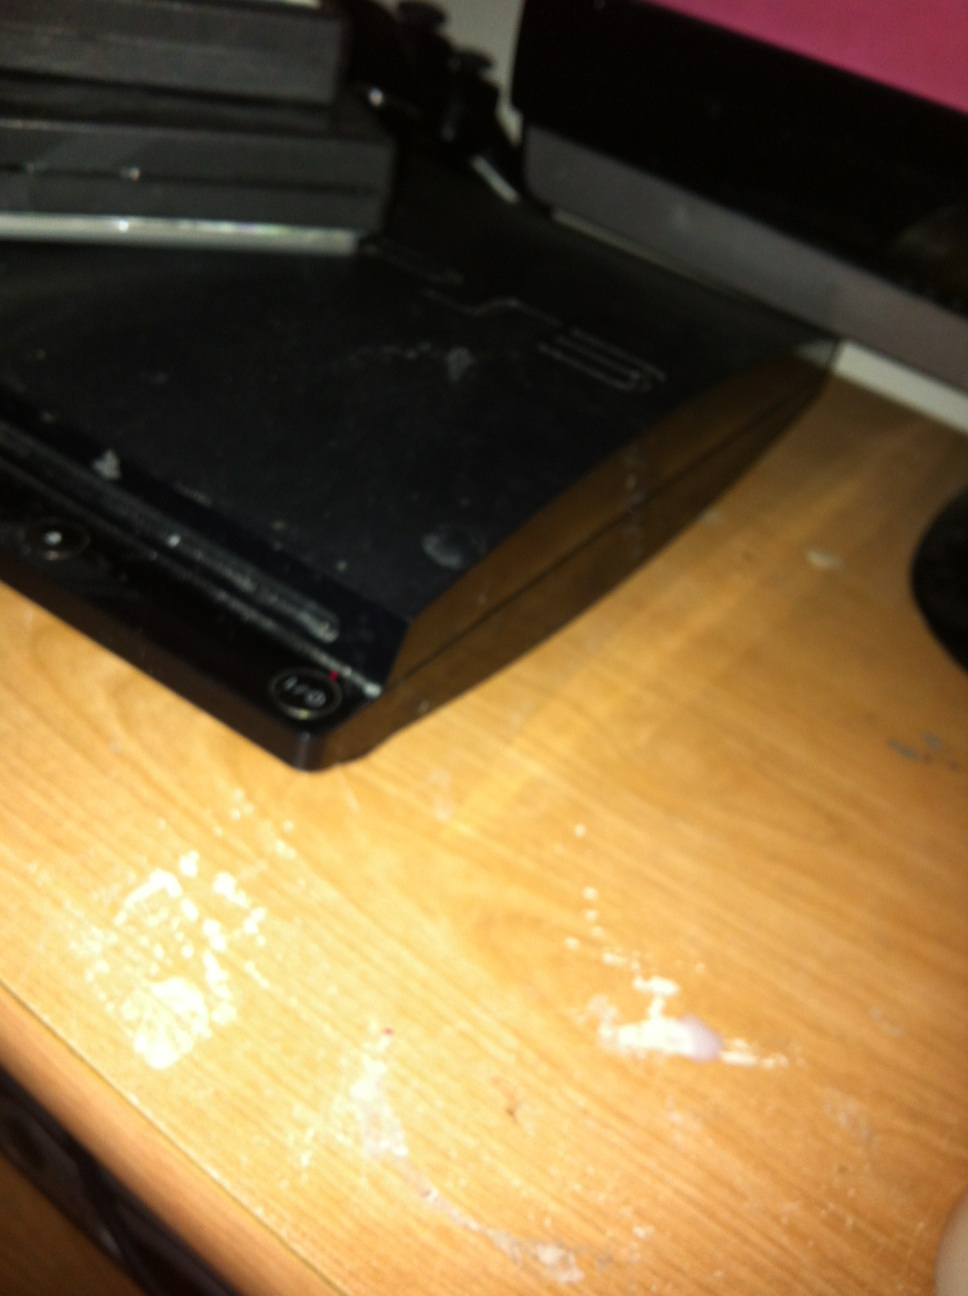What is this? This is an image of a PlayStation 3, a gaming console developed by Sony. It is known for its sleek design and as part of the PlayStation series, which includes other models such as the PlayStation 2 and PlayStation 4. 